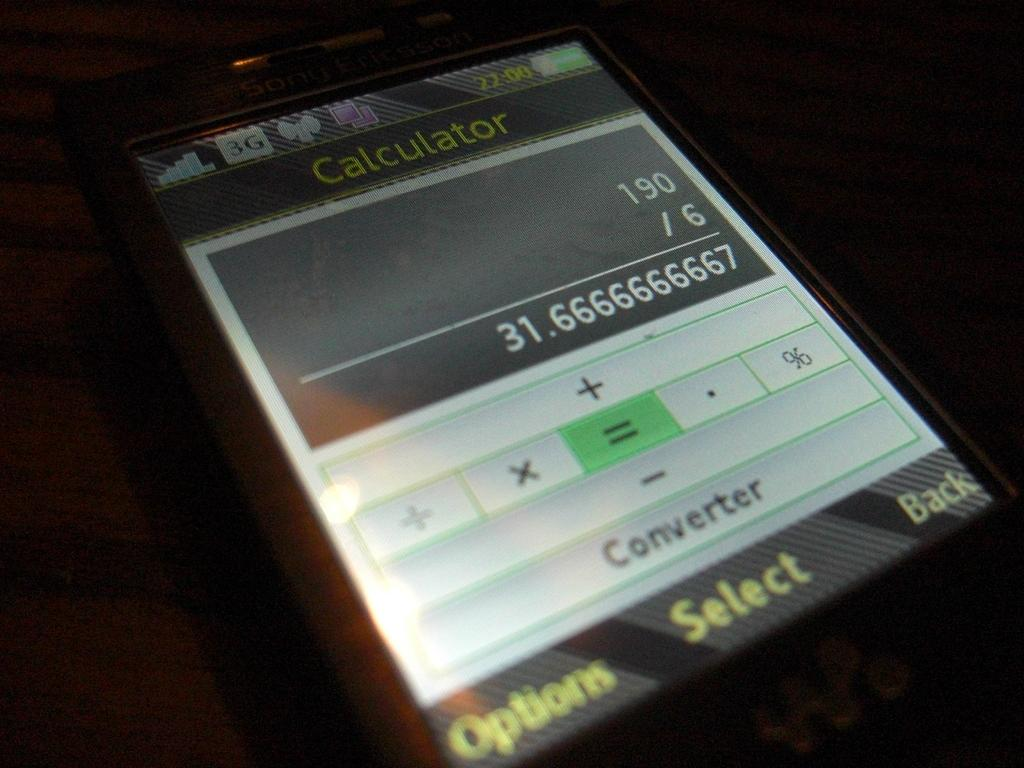<image>
Give a short and clear explanation of the subsequent image. a calculator showing the answer to 190/6 as being 31.6 